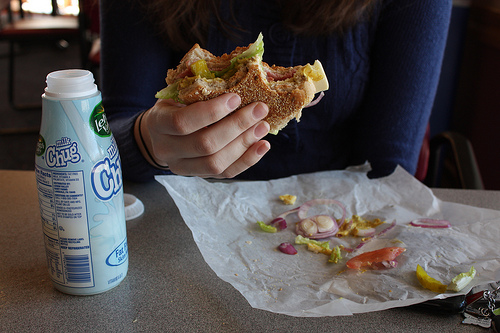<image>
Can you confirm if the burger is on the wrapper? No. The burger is not positioned on the wrapper. They may be near each other, but the burger is not supported by or resting on top of the wrapper. 